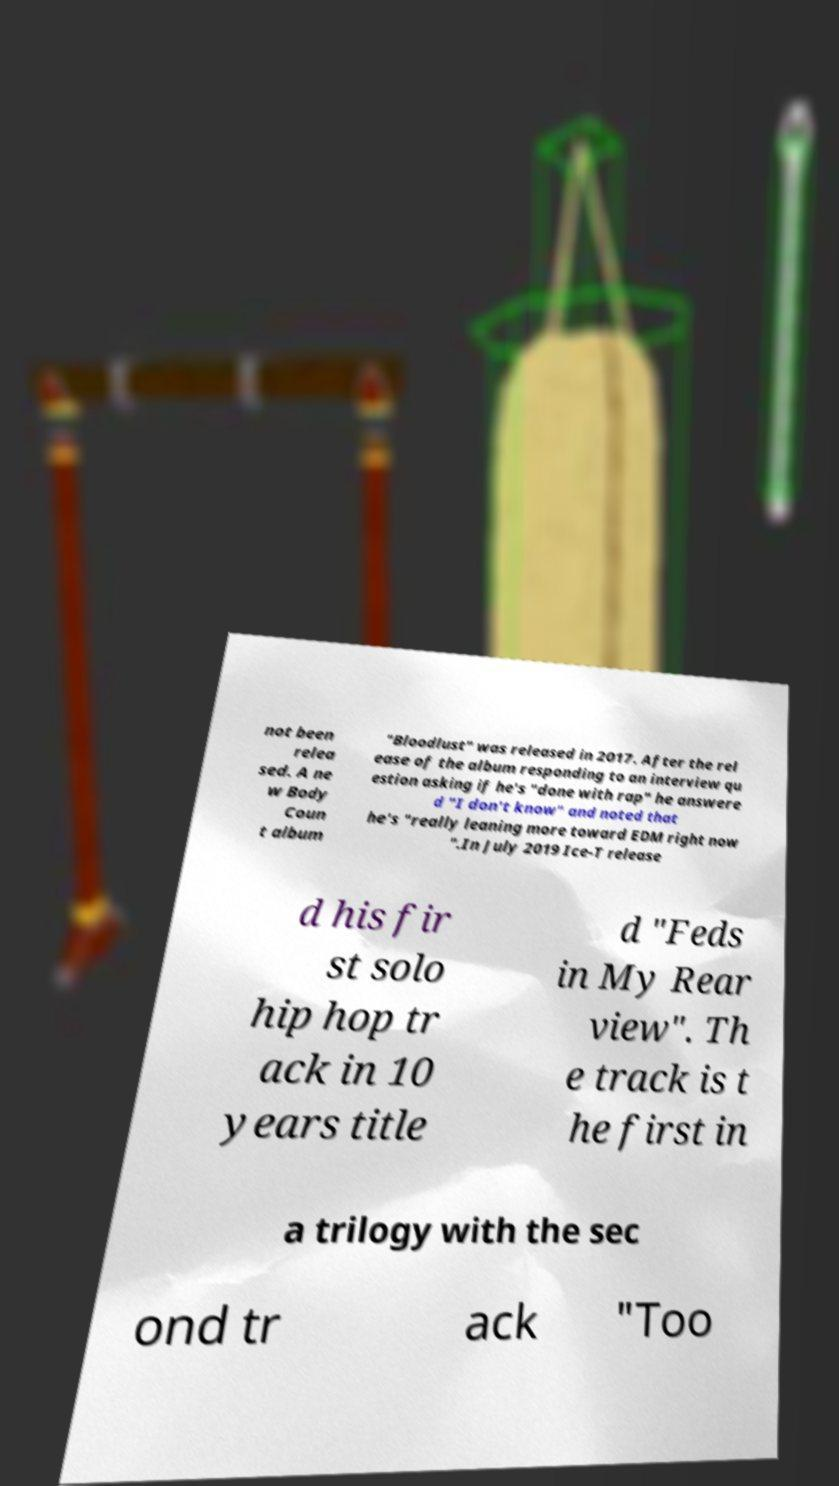For documentation purposes, I need the text within this image transcribed. Could you provide that? not been relea sed. A ne w Body Coun t album "Bloodlust" was released in 2017. After the rel ease of the album responding to an interview qu estion asking if he's "done with rap" he answere d "I don't know" and noted that he's "really leaning more toward EDM right now ".In July 2019 Ice-T release d his fir st solo hip hop tr ack in 10 years title d "Feds in My Rear view". Th e track is t he first in a trilogy with the sec ond tr ack "Too 